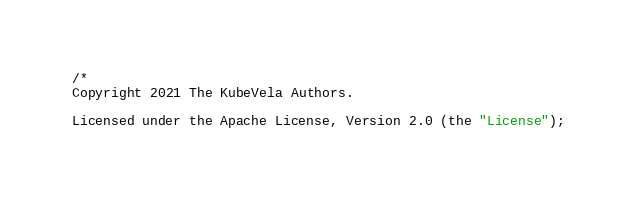<code> <loc_0><loc_0><loc_500><loc_500><_Go_>/*
Copyright 2021 The KubeVela Authors.

Licensed under the Apache License, Version 2.0 (the "License");</code> 